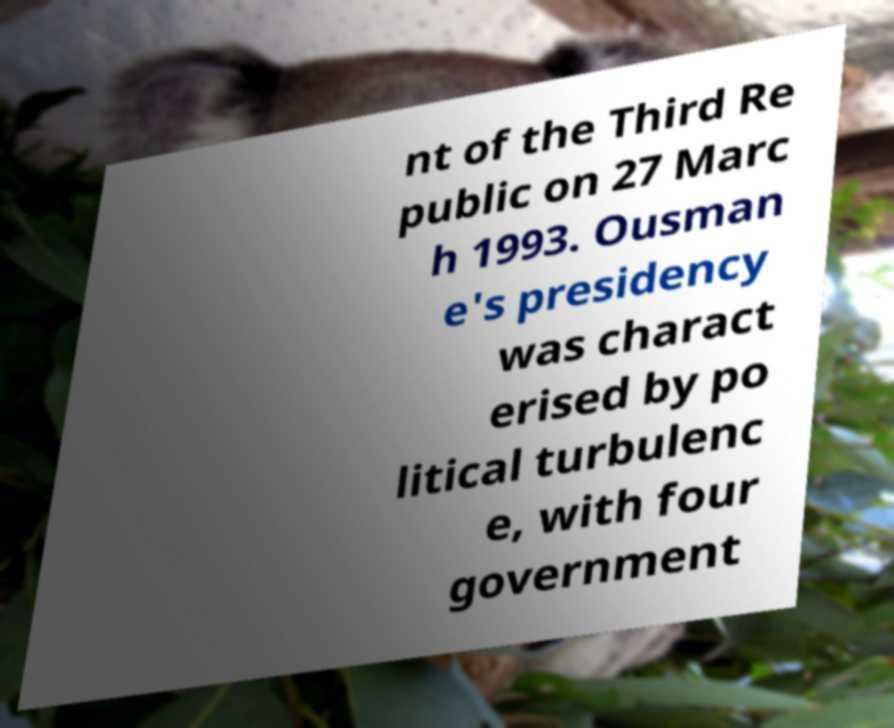There's text embedded in this image that I need extracted. Can you transcribe it verbatim? nt of the Third Re public on 27 Marc h 1993. Ousman e's presidency was charact erised by po litical turbulenc e, with four government 